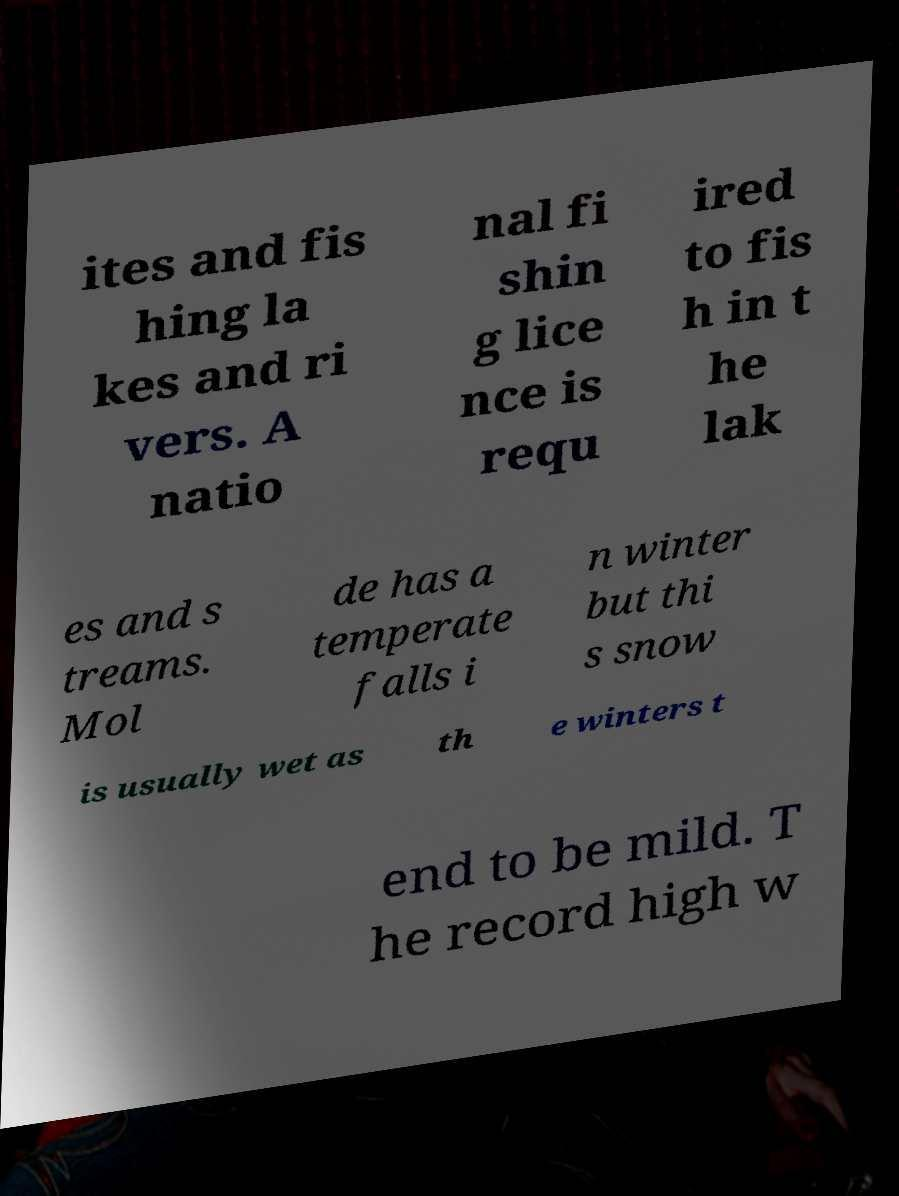For documentation purposes, I need the text within this image transcribed. Could you provide that? ites and fis hing la kes and ri vers. A natio nal fi shin g lice nce is requ ired to fis h in t he lak es and s treams. Mol de has a temperate falls i n winter but thi s snow is usually wet as th e winters t end to be mild. T he record high w 